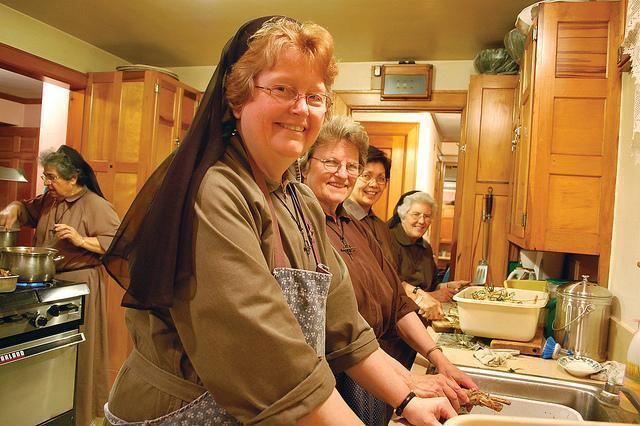What profession are these women in?
Indicate the correct response by choosing from the four available options to answer the question.
Options: Nurses, cashiers, teachers, nuns. Nuns. 